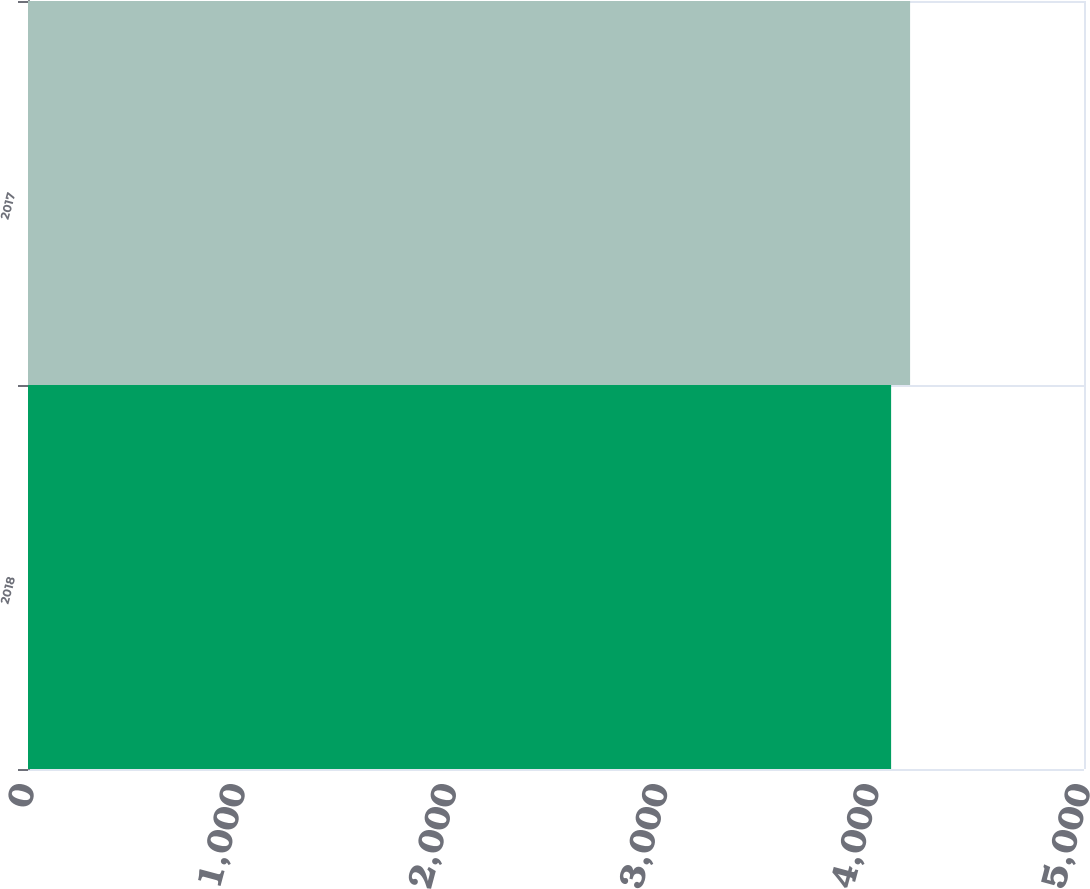Convert chart to OTSL. <chart><loc_0><loc_0><loc_500><loc_500><bar_chart><fcel>2018<fcel>2017<nl><fcel>4086.7<fcel>4176.6<nl></chart> 